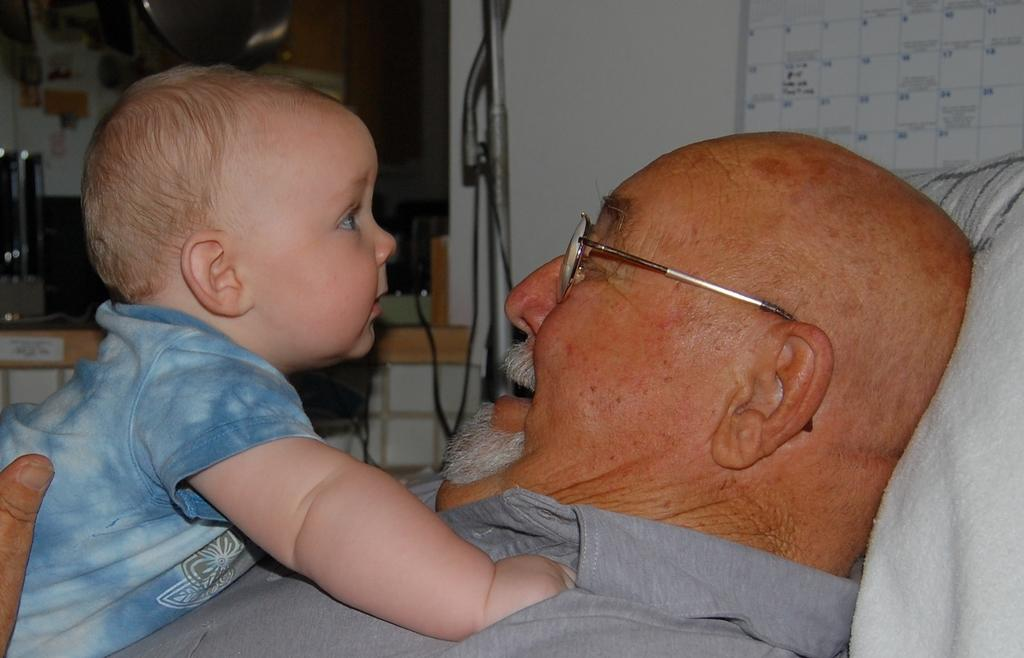Who is the main subject in the image? There is an old man in the image. What is the old man doing in the image? The old man is looking at a baby in the image. Where is the baby located in the image? The baby is on the left side of the image. What is the baby wearing in the image? The baby is wearing a t-shirt in the image. What type of magic is the old man performing on the baby in the image? There is no magic or any indication of magic being performed in the image. 